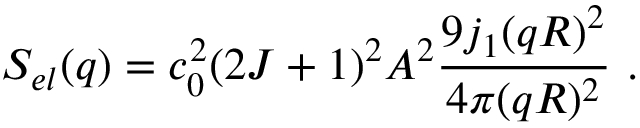<formula> <loc_0><loc_0><loc_500><loc_500>S _ { e l } ( q ) = c _ { 0 } ^ { 2 } ( 2 J + 1 ) ^ { 2 } A ^ { 2 } \frac { 9 j _ { 1 } ( q R ) ^ { 2 } } { 4 \pi ( q R ) ^ { 2 } } .</formula> 